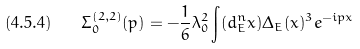<formula> <loc_0><loc_0><loc_500><loc_500>( 4 . 5 . 4 ) \quad \Sigma _ { 0 } ^ { ( 2 , 2 ) } ( p ) = - \frac { 1 } { 6 } \lambda _ { 0 } ^ { 2 } \int ( d _ { E } ^ { n } x ) \Delta _ { E } ( x ) ^ { 3 } e ^ { - i p x }</formula> 